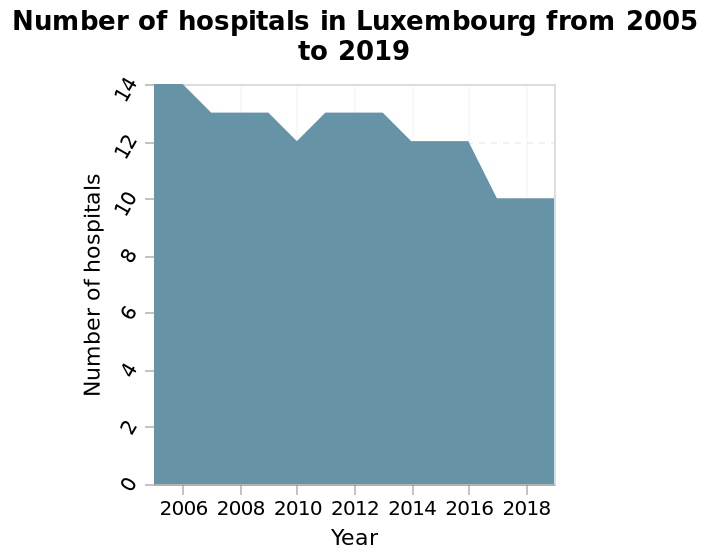<image>
How many hospitals were there in Luxembourg in 2019?  The number of hospitals in Luxembourg in 2019 is not mentioned in the description. What does the x-axis in the area diagram represent?  The x-axis in the area diagram represents the Years from 2005 to 2019. please enumerates aspects of the construction of the chart This is a area diagram labeled Number of hospitals in Luxembourg from 2005 to 2019. The x-axis measures Year while the y-axis measures Number of hospitals. What is the purpose of the area diagram? The purpose of the area diagram is to visualize the trend and changes in the Number of hospitals in Luxembourg over the years from 2005 to 2019. What was the highest number of hospitals in Luxembourg?  The highest number of hospitals in Luxembourg was 14 in 2005. 